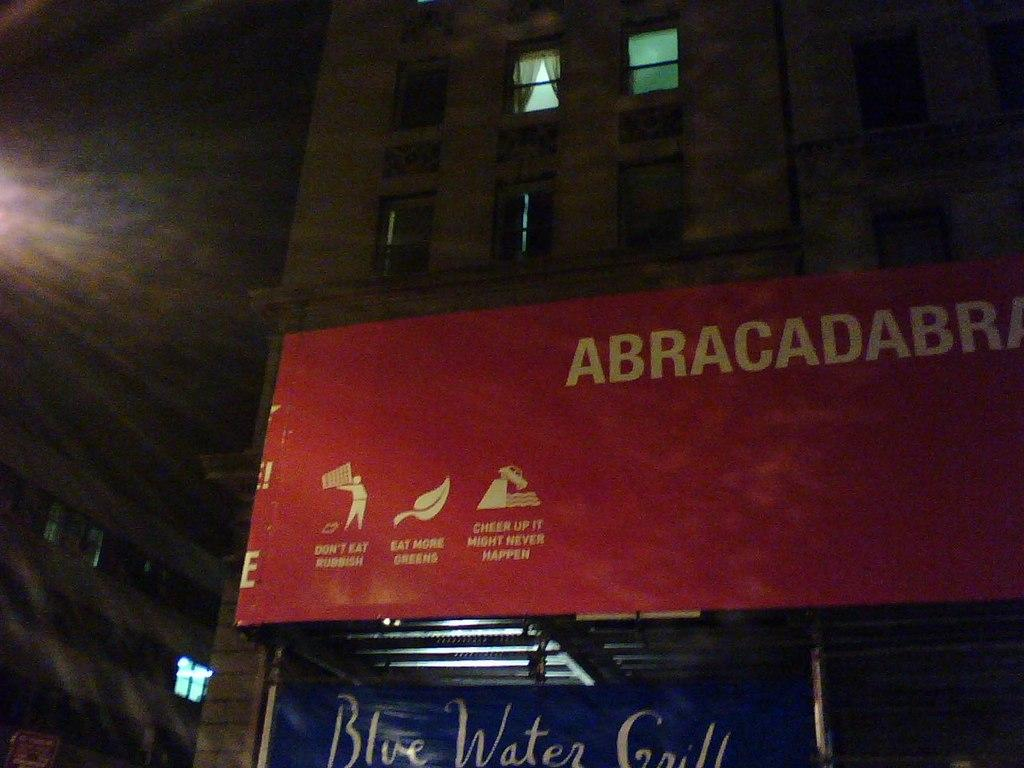Provide a one-sentence caption for the provided image. Red banner strung across the building front stating "Abracadabra" and "Don't eat rubbish, eat more greens, cheer up it might never happen". 